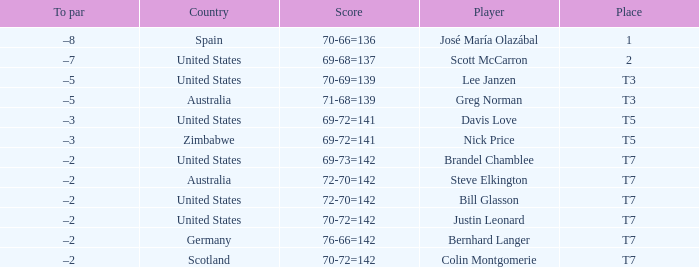Name the Player who has a Country of united states, and a To par of –5? Lee Janzen. 